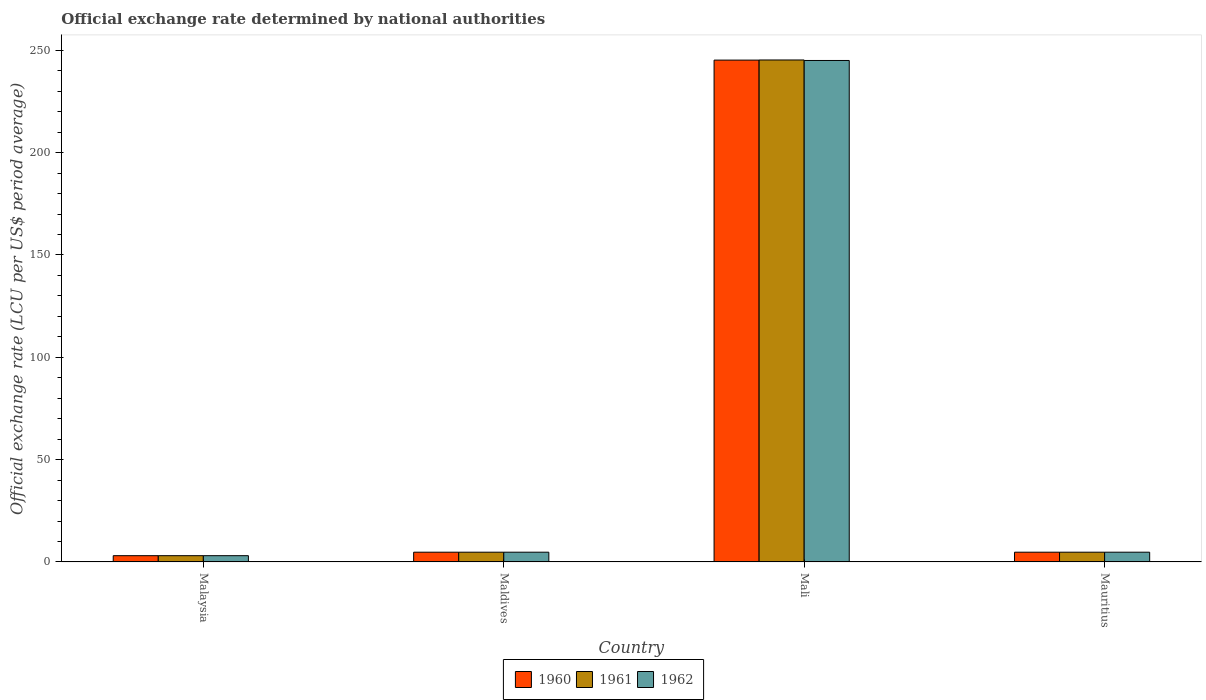How many different coloured bars are there?
Give a very brief answer. 3. How many groups of bars are there?
Give a very brief answer. 4. What is the label of the 2nd group of bars from the left?
Your answer should be very brief. Maldives. In how many cases, is the number of bars for a given country not equal to the number of legend labels?
Offer a very short reply. 0. What is the official exchange rate in 1961 in Mali?
Provide a succinct answer. 245.26. Across all countries, what is the maximum official exchange rate in 1962?
Make the answer very short. 245.01. Across all countries, what is the minimum official exchange rate in 1961?
Your answer should be very brief. 3.06. In which country was the official exchange rate in 1962 maximum?
Ensure brevity in your answer.  Mali. In which country was the official exchange rate in 1962 minimum?
Your answer should be compact. Malaysia. What is the total official exchange rate in 1962 in the graph?
Your response must be concise. 257.6. What is the difference between the official exchange rate in 1960 in Mali and that in Mauritius?
Ensure brevity in your answer.  240.43. What is the difference between the official exchange rate in 1961 in Maldives and the official exchange rate in 1962 in Malaysia?
Your answer should be compact. 1.7. What is the average official exchange rate in 1961 per country?
Give a very brief answer. 64.46. What is the difference between the official exchange rate of/in 1962 and official exchange rate of/in 1960 in Malaysia?
Keep it short and to the point. 0. What is the ratio of the official exchange rate in 1962 in Mali to that in Mauritius?
Provide a short and direct response. 51.45. Is the official exchange rate in 1961 in Maldives less than that in Mali?
Make the answer very short. Yes. Is the difference between the official exchange rate in 1962 in Mali and Mauritius greater than the difference between the official exchange rate in 1960 in Mali and Mauritius?
Offer a terse response. No. What is the difference between the highest and the second highest official exchange rate in 1962?
Keep it short and to the point. -240.25. What is the difference between the highest and the lowest official exchange rate in 1960?
Make the answer very short. 242.13. What does the 1st bar from the right in Mali represents?
Your answer should be very brief. 1962. Is it the case that in every country, the sum of the official exchange rate in 1962 and official exchange rate in 1961 is greater than the official exchange rate in 1960?
Your answer should be compact. Yes. How many bars are there?
Provide a short and direct response. 12. How many countries are there in the graph?
Your response must be concise. 4. Does the graph contain grids?
Your response must be concise. No. Where does the legend appear in the graph?
Provide a succinct answer. Bottom center. How many legend labels are there?
Keep it short and to the point. 3. What is the title of the graph?
Ensure brevity in your answer.  Official exchange rate determined by national authorities. Does "1964" appear as one of the legend labels in the graph?
Provide a short and direct response. No. What is the label or title of the X-axis?
Your answer should be compact. Country. What is the label or title of the Y-axis?
Provide a succinct answer. Official exchange rate (LCU per US$ period average). What is the Official exchange rate (LCU per US$ period average) in 1960 in Malaysia?
Give a very brief answer. 3.06. What is the Official exchange rate (LCU per US$ period average) in 1961 in Malaysia?
Make the answer very short. 3.06. What is the Official exchange rate (LCU per US$ period average) of 1962 in Malaysia?
Give a very brief answer. 3.06. What is the Official exchange rate (LCU per US$ period average) in 1960 in Maldives?
Offer a terse response. 4.76. What is the Official exchange rate (LCU per US$ period average) in 1961 in Maldives?
Your answer should be compact. 4.76. What is the Official exchange rate (LCU per US$ period average) in 1962 in Maldives?
Your response must be concise. 4.76. What is the Official exchange rate (LCU per US$ period average) in 1960 in Mali?
Offer a very short reply. 245.2. What is the Official exchange rate (LCU per US$ period average) of 1961 in Mali?
Make the answer very short. 245.26. What is the Official exchange rate (LCU per US$ period average) of 1962 in Mali?
Provide a short and direct response. 245.01. What is the Official exchange rate (LCU per US$ period average) of 1960 in Mauritius?
Keep it short and to the point. 4.76. What is the Official exchange rate (LCU per US$ period average) of 1961 in Mauritius?
Provide a short and direct response. 4.76. What is the Official exchange rate (LCU per US$ period average) of 1962 in Mauritius?
Your answer should be compact. 4.76. Across all countries, what is the maximum Official exchange rate (LCU per US$ period average) of 1960?
Provide a short and direct response. 245.2. Across all countries, what is the maximum Official exchange rate (LCU per US$ period average) of 1961?
Your answer should be compact. 245.26. Across all countries, what is the maximum Official exchange rate (LCU per US$ period average) in 1962?
Provide a short and direct response. 245.01. Across all countries, what is the minimum Official exchange rate (LCU per US$ period average) in 1960?
Give a very brief answer. 3.06. Across all countries, what is the minimum Official exchange rate (LCU per US$ period average) of 1961?
Your answer should be very brief. 3.06. Across all countries, what is the minimum Official exchange rate (LCU per US$ period average) of 1962?
Your response must be concise. 3.06. What is the total Official exchange rate (LCU per US$ period average) in 1960 in the graph?
Your response must be concise. 257.78. What is the total Official exchange rate (LCU per US$ period average) in 1961 in the graph?
Ensure brevity in your answer.  257.85. What is the total Official exchange rate (LCU per US$ period average) of 1962 in the graph?
Keep it short and to the point. 257.6. What is the difference between the Official exchange rate (LCU per US$ period average) in 1960 in Malaysia and that in Maldives?
Your answer should be compact. -1.7. What is the difference between the Official exchange rate (LCU per US$ period average) in 1961 in Malaysia and that in Maldives?
Your response must be concise. -1.7. What is the difference between the Official exchange rate (LCU per US$ period average) in 1962 in Malaysia and that in Maldives?
Your answer should be compact. -1.7. What is the difference between the Official exchange rate (LCU per US$ period average) in 1960 in Malaysia and that in Mali?
Give a very brief answer. -242.13. What is the difference between the Official exchange rate (LCU per US$ period average) in 1961 in Malaysia and that in Mali?
Your answer should be compact. -242.2. What is the difference between the Official exchange rate (LCU per US$ period average) of 1962 in Malaysia and that in Mali?
Give a very brief answer. -241.95. What is the difference between the Official exchange rate (LCU per US$ period average) of 1960 in Malaysia and that in Mauritius?
Provide a succinct answer. -1.7. What is the difference between the Official exchange rate (LCU per US$ period average) in 1961 in Malaysia and that in Mauritius?
Give a very brief answer. -1.7. What is the difference between the Official exchange rate (LCU per US$ period average) of 1962 in Malaysia and that in Mauritius?
Your response must be concise. -1.7. What is the difference between the Official exchange rate (LCU per US$ period average) in 1960 in Maldives and that in Mali?
Provide a short and direct response. -240.43. What is the difference between the Official exchange rate (LCU per US$ period average) in 1961 in Maldives and that in Mali?
Offer a very short reply. -240.5. What is the difference between the Official exchange rate (LCU per US$ period average) of 1962 in Maldives and that in Mali?
Your answer should be very brief. -240.25. What is the difference between the Official exchange rate (LCU per US$ period average) of 1960 in Maldives and that in Mauritius?
Provide a succinct answer. 0. What is the difference between the Official exchange rate (LCU per US$ period average) of 1960 in Mali and that in Mauritius?
Make the answer very short. 240.43. What is the difference between the Official exchange rate (LCU per US$ period average) of 1961 in Mali and that in Mauritius?
Offer a terse response. 240.5. What is the difference between the Official exchange rate (LCU per US$ period average) in 1962 in Mali and that in Mauritius?
Keep it short and to the point. 240.25. What is the difference between the Official exchange rate (LCU per US$ period average) in 1960 in Malaysia and the Official exchange rate (LCU per US$ period average) in 1961 in Maldives?
Keep it short and to the point. -1.7. What is the difference between the Official exchange rate (LCU per US$ period average) in 1960 in Malaysia and the Official exchange rate (LCU per US$ period average) in 1962 in Maldives?
Your answer should be compact. -1.7. What is the difference between the Official exchange rate (LCU per US$ period average) in 1961 in Malaysia and the Official exchange rate (LCU per US$ period average) in 1962 in Maldives?
Ensure brevity in your answer.  -1.7. What is the difference between the Official exchange rate (LCU per US$ period average) of 1960 in Malaysia and the Official exchange rate (LCU per US$ period average) of 1961 in Mali?
Provide a short and direct response. -242.2. What is the difference between the Official exchange rate (LCU per US$ period average) in 1960 in Malaysia and the Official exchange rate (LCU per US$ period average) in 1962 in Mali?
Make the answer very short. -241.95. What is the difference between the Official exchange rate (LCU per US$ period average) in 1961 in Malaysia and the Official exchange rate (LCU per US$ period average) in 1962 in Mali?
Keep it short and to the point. -241.95. What is the difference between the Official exchange rate (LCU per US$ period average) of 1960 in Malaysia and the Official exchange rate (LCU per US$ period average) of 1961 in Mauritius?
Keep it short and to the point. -1.7. What is the difference between the Official exchange rate (LCU per US$ period average) of 1960 in Malaysia and the Official exchange rate (LCU per US$ period average) of 1962 in Mauritius?
Provide a succinct answer. -1.7. What is the difference between the Official exchange rate (LCU per US$ period average) in 1961 in Malaysia and the Official exchange rate (LCU per US$ period average) in 1962 in Mauritius?
Make the answer very short. -1.7. What is the difference between the Official exchange rate (LCU per US$ period average) of 1960 in Maldives and the Official exchange rate (LCU per US$ period average) of 1961 in Mali?
Offer a terse response. -240.5. What is the difference between the Official exchange rate (LCU per US$ period average) in 1960 in Maldives and the Official exchange rate (LCU per US$ period average) in 1962 in Mali?
Offer a very short reply. -240.25. What is the difference between the Official exchange rate (LCU per US$ period average) of 1961 in Maldives and the Official exchange rate (LCU per US$ period average) of 1962 in Mali?
Offer a very short reply. -240.25. What is the difference between the Official exchange rate (LCU per US$ period average) of 1960 in Mali and the Official exchange rate (LCU per US$ period average) of 1961 in Mauritius?
Give a very brief answer. 240.43. What is the difference between the Official exchange rate (LCU per US$ period average) of 1960 in Mali and the Official exchange rate (LCU per US$ period average) of 1962 in Mauritius?
Ensure brevity in your answer.  240.43. What is the difference between the Official exchange rate (LCU per US$ period average) of 1961 in Mali and the Official exchange rate (LCU per US$ period average) of 1962 in Mauritius?
Your answer should be very brief. 240.5. What is the average Official exchange rate (LCU per US$ period average) in 1960 per country?
Keep it short and to the point. 64.44. What is the average Official exchange rate (LCU per US$ period average) in 1961 per country?
Your answer should be compact. 64.46. What is the average Official exchange rate (LCU per US$ period average) of 1962 per country?
Ensure brevity in your answer.  64.4. What is the difference between the Official exchange rate (LCU per US$ period average) in 1960 and Official exchange rate (LCU per US$ period average) in 1961 in Malaysia?
Your answer should be very brief. 0. What is the difference between the Official exchange rate (LCU per US$ period average) in 1961 and Official exchange rate (LCU per US$ period average) in 1962 in Malaysia?
Offer a very short reply. 0. What is the difference between the Official exchange rate (LCU per US$ period average) in 1960 and Official exchange rate (LCU per US$ period average) in 1961 in Maldives?
Make the answer very short. 0. What is the difference between the Official exchange rate (LCU per US$ period average) in 1960 and Official exchange rate (LCU per US$ period average) in 1962 in Maldives?
Offer a very short reply. 0. What is the difference between the Official exchange rate (LCU per US$ period average) of 1960 and Official exchange rate (LCU per US$ period average) of 1961 in Mali?
Offer a very short reply. -0.07. What is the difference between the Official exchange rate (LCU per US$ period average) in 1960 and Official exchange rate (LCU per US$ period average) in 1962 in Mali?
Your answer should be very brief. 0.18. What is the difference between the Official exchange rate (LCU per US$ period average) of 1961 and Official exchange rate (LCU per US$ period average) of 1962 in Mali?
Provide a short and direct response. 0.25. What is the ratio of the Official exchange rate (LCU per US$ period average) in 1960 in Malaysia to that in Maldives?
Provide a short and direct response. 0.64. What is the ratio of the Official exchange rate (LCU per US$ period average) in 1961 in Malaysia to that in Maldives?
Make the answer very short. 0.64. What is the ratio of the Official exchange rate (LCU per US$ period average) in 1962 in Malaysia to that in Maldives?
Provide a succinct answer. 0.64. What is the ratio of the Official exchange rate (LCU per US$ period average) of 1960 in Malaysia to that in Mali?
Your answer should be very brief. 0.01. What is the ratio of the Official exchange rate (LCU per US$ period average) of 1961 in Malaysia to that in Mali?
Ensure brevity in your answer.  0.01. What is the ratio of the Official exchange rate (LCU per US$ period average) in 1962 in Malaysia to that in Mali?
Provide a short and direct response. 0.01. What is the ratio of the Official exchange rate (LCU per US$ period average) in 1960 in Malaysia to that in Mauritius?
Keep it short and to the point. 0.64. What is the ratio of the Official exchange rate (LCU per US$ period average) in 1961 in Malaysia to that in Mauritius?
Make the answer very short. 0.64. What is the ratio of the Official exchange rate (LCU per US$ period average) of 1962 in Malaysia to that in Mauritius?
Provide a short and direct response. 0.64. What is the ratio of the Official exchange rate (LCU per US$ period average) of 1960 in Maldives to that in Mali?
Make the answer very short. 0.02. What is the ratio of the Official exchange rate (LCU per US$ period average) in 1961 in Maldives to that in Mali?
Offer a terse response. 0.02. What is the ratio of the Official exchange rate (LCU per US$ period average) in 1962 in Maldives to that in Mali?
Your response must be concise. 0.02. What is the ratio of the Official exchange rate (LCU per US$ period average) of 1962 in Maldives to that in Mauritius?
Provide a succinct answer. 1. What is the ratio of the Official exchange rate (LCU per US$ period average) of 1960 in Mali to that in Mauritius?
Keep it short and to the point. 51.49. What is the ratio of the Official exchange rate (LCU per US$ period average) of 1961 in Mali to that in Mauritius?
Provide a short and direct response. 51.5. What is the ratio of the Official exchange rate (LCU per US$ period average) in 1962 in Mali to that in Mauritius?
Provide a short and direct response. 51.45. What is the difference between the highest and the second highest Official exchange rate (LCU per US$ period average) in 1960?
Make the answer very short. 240.43. What is the difference between the highest and the second highest Official exchange rate (LCU per US$ period average) in 1961?
Offer a very short reply. 240.5. What is the difference between the highest and the second highest Official exchange rate (LCU per US$ period average) of 1962?
Your answer should be compact. 240.25. What is the difference between the highest and the lowest Official exchange rate (LCU per US$ period average) of 1960?
Your answer should be compact. 242.13. What is the difference between the highest and the lowest Official exchange rate (LCU per US$ period average) of 1961?
Keep it short and to the point. 242.2. What is the difference between the highest and the lowest Official exchange rate (LCU per US$ period average) of 1962?
Your answer should be compact. 241.95. 